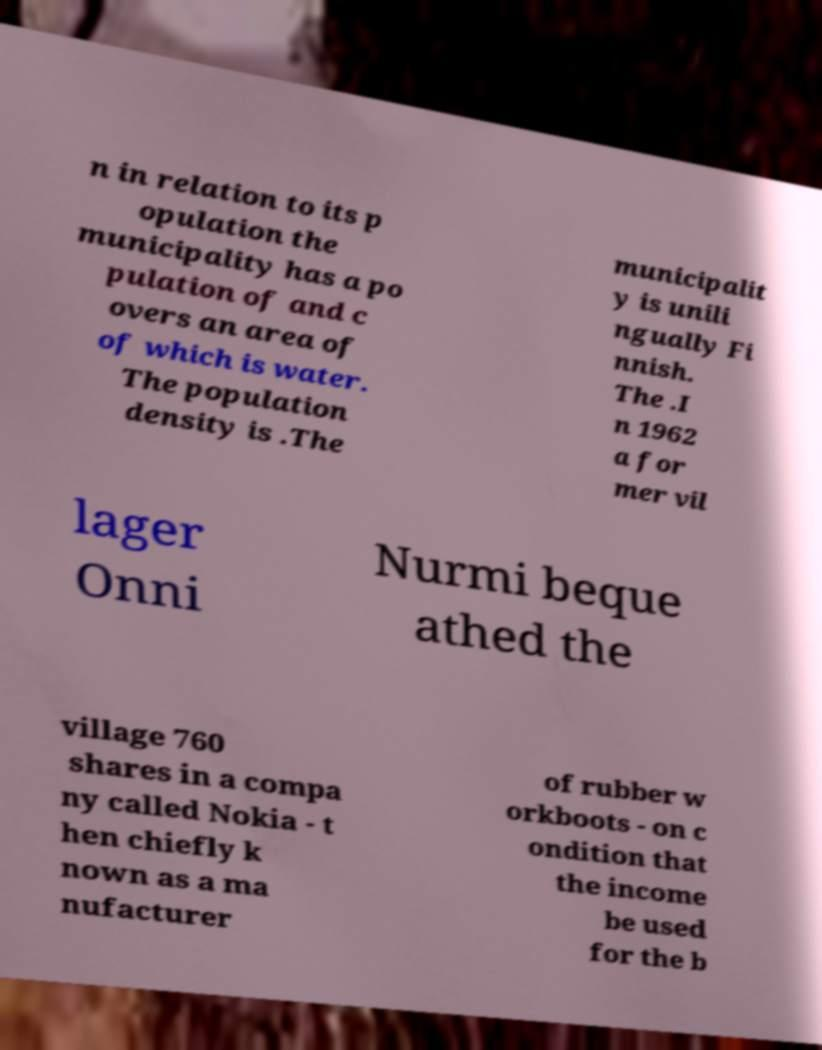Can you accurately transcribe the text from the provided image for me? n in relation to its p opulation the municipality has a po pulation of and c overs an area of of which is water. The population density is .The municipalit y is unili ngually Fi nnish. The .I n 1962 a for mer vil lager Onni Nurmi beque athed the village 760 shares in a compa ny called Nokia - t hen chiefly k nown as a ma nufacturer of rubber w orkboots - on c ondition that the income be used for the b 